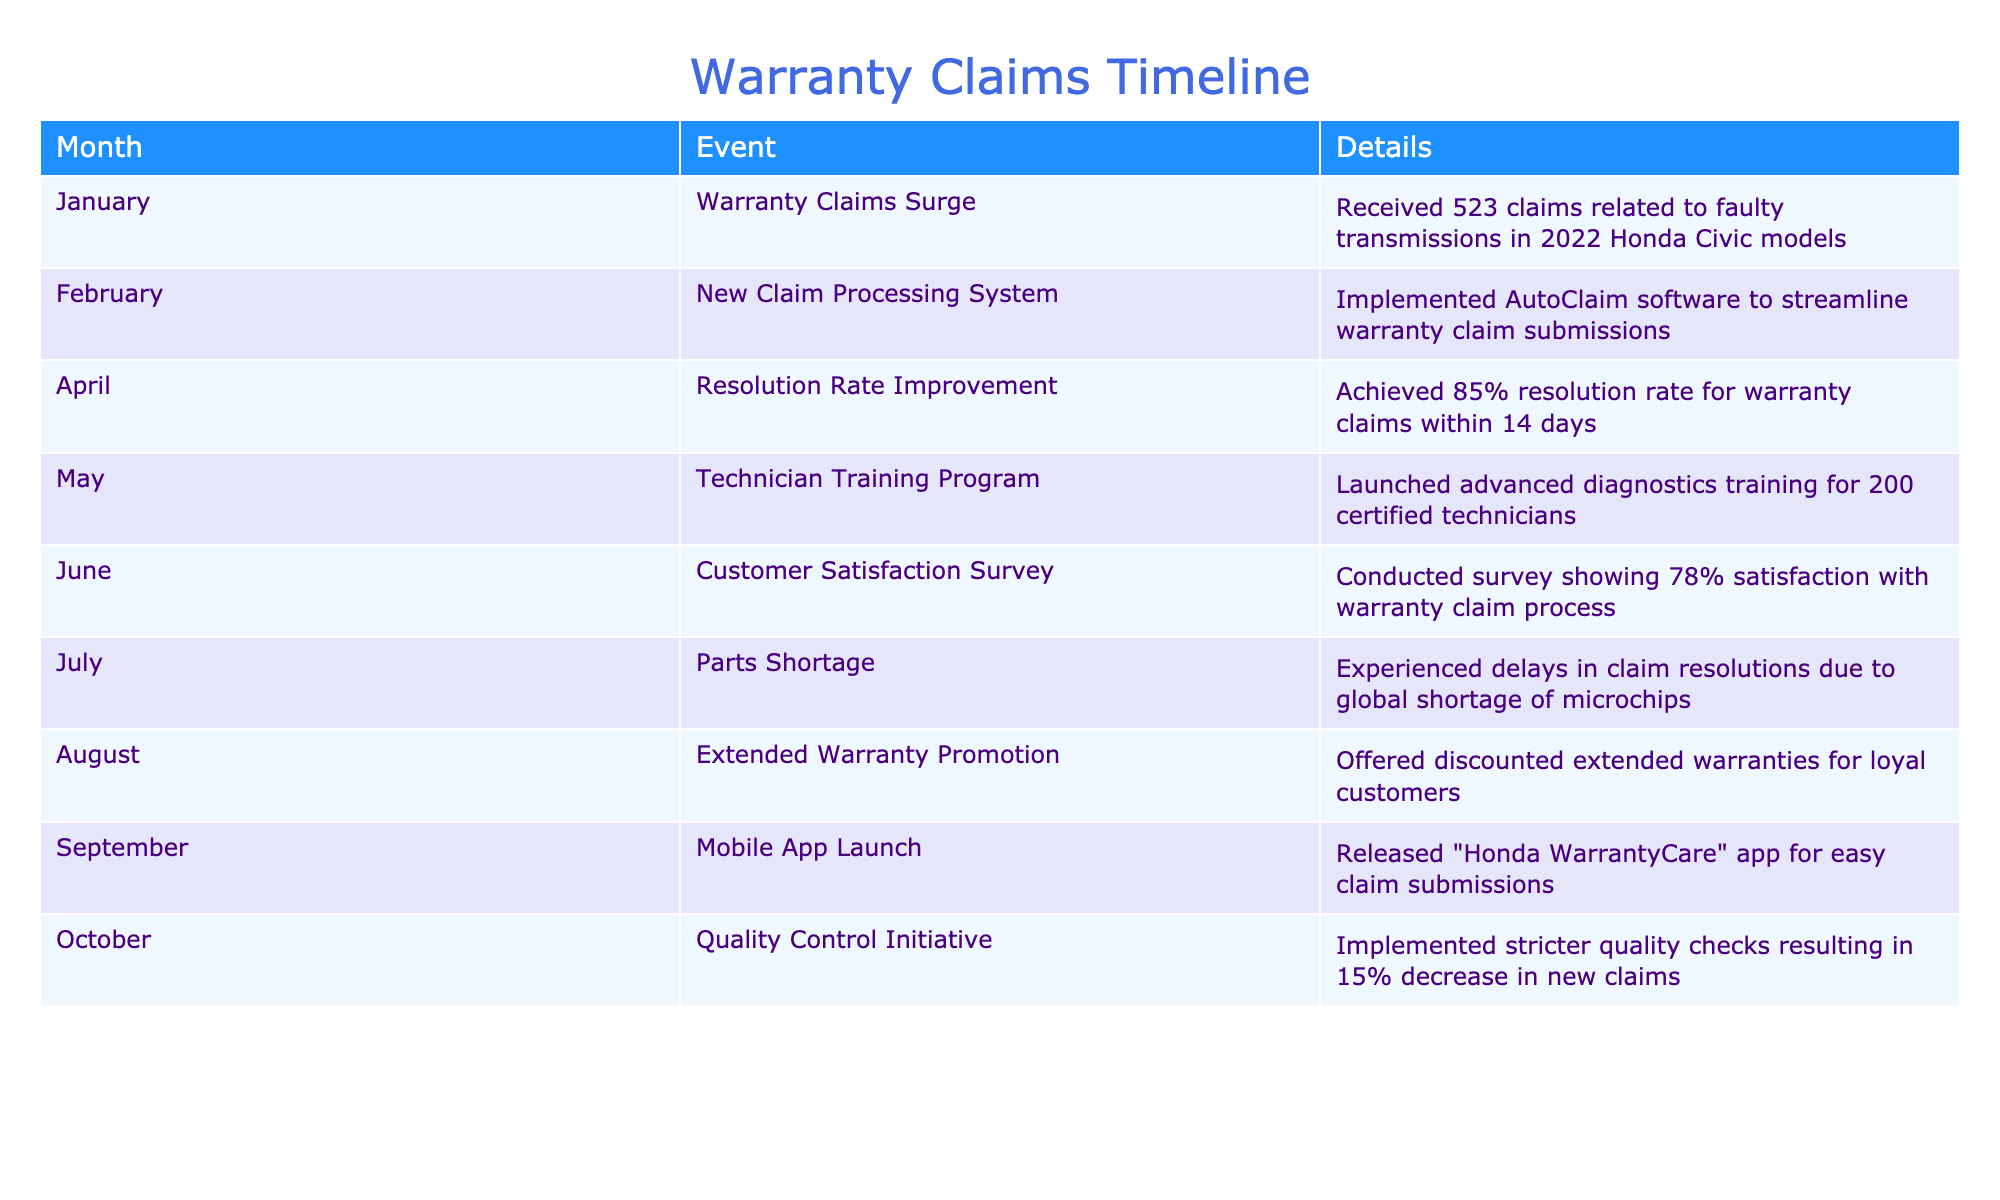What was the total number of warranty claims received in January? In January, the table indicates that 523 warranty claims were received specifically related to faulty transmissions in 2022 Honda Civic models.
Answer: 523 What was the resolution rate for warranty claims achieved in April? The table states that an achievement of 85% resolution rate for warranty claims was reached within 14 days in April.
Answer: 85% Did the launch of the "Honda WarrantyCare" app happen before or after the technician training program? According to the table, the technician training program was launched in May, and the mobile app launch was in September. Therefore, the app was launched after the training program.
Answer: After What percentage of customers expressed satisfaction with the warranty claim process in June? The table shows that a customer satisfaction survey conducted in June revealed a satisfaction level of 78% with the warranty claim process.
Answer: 78% How many months experienced delays in claim resolutions due to parts shortages? The table specifies that the parts shortage was experienced in July, meaning only one month, July, had this issue.
Answer: 1 What is the difference in the number of events reported in the first half of the year compared to the second half of the year? The first half of the year (January to June) has 6 events. The second half (July to October) has 4 events. The difference is 6 - 4 = 2.
Answer: 2 Was there a quality control initiative that led to a decrease in new claims? The table indicates that in October, a quality control initiative was implemented which resulted in a 15% decrease in new claims. Therefore, the statement is true.
Answer: Yes What was the main cause for the surge in warranty claims in January? The table clearly states that the January surge in warranty claims was related to faulty transmissions in the 2022 Honda Civic models.
Answer: Faulty transmissions What event in March is not mentioned in the timeline? The timeline does not specify any events taking place in March, as March is not listed in the table, indicating no recorded events for that month.
Answer: None 